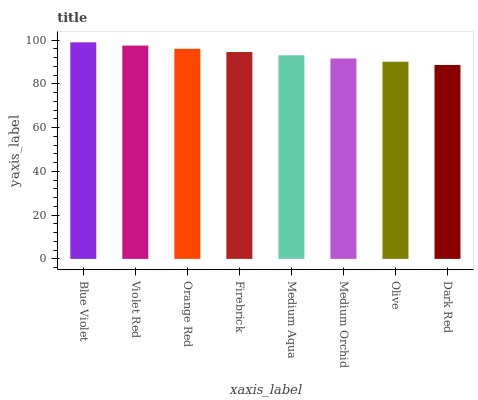Is Dark Red the minimum?
Answer yes or no. Yes. Is Blue Violet the maximum?
Answer yes or no. Yes. Is Violet Red the minimum?
Answer yes or no. No. Is Violet Red the maximum?
Answer yes or no. No. Is Blue Violet greater than Violet Red?
Answer yes or no. Yes. Is Violet Red less than Blue Violet?
Answer yes or no. Yes. Is Violet Red greater than Blue Violet?
Answer yes or no. No. Is Blue Violet less than Violet Red?
Answer yes or no. No. Is Firebrick the high median?
Answer yes or no. Yes. Is Medium Aqua the low median?
Answer yes or no. Yes. Is Medium Orchid the high median?
Answer yes or no. No. Is Blue Violet the low median?
Answer yes or no. No. 